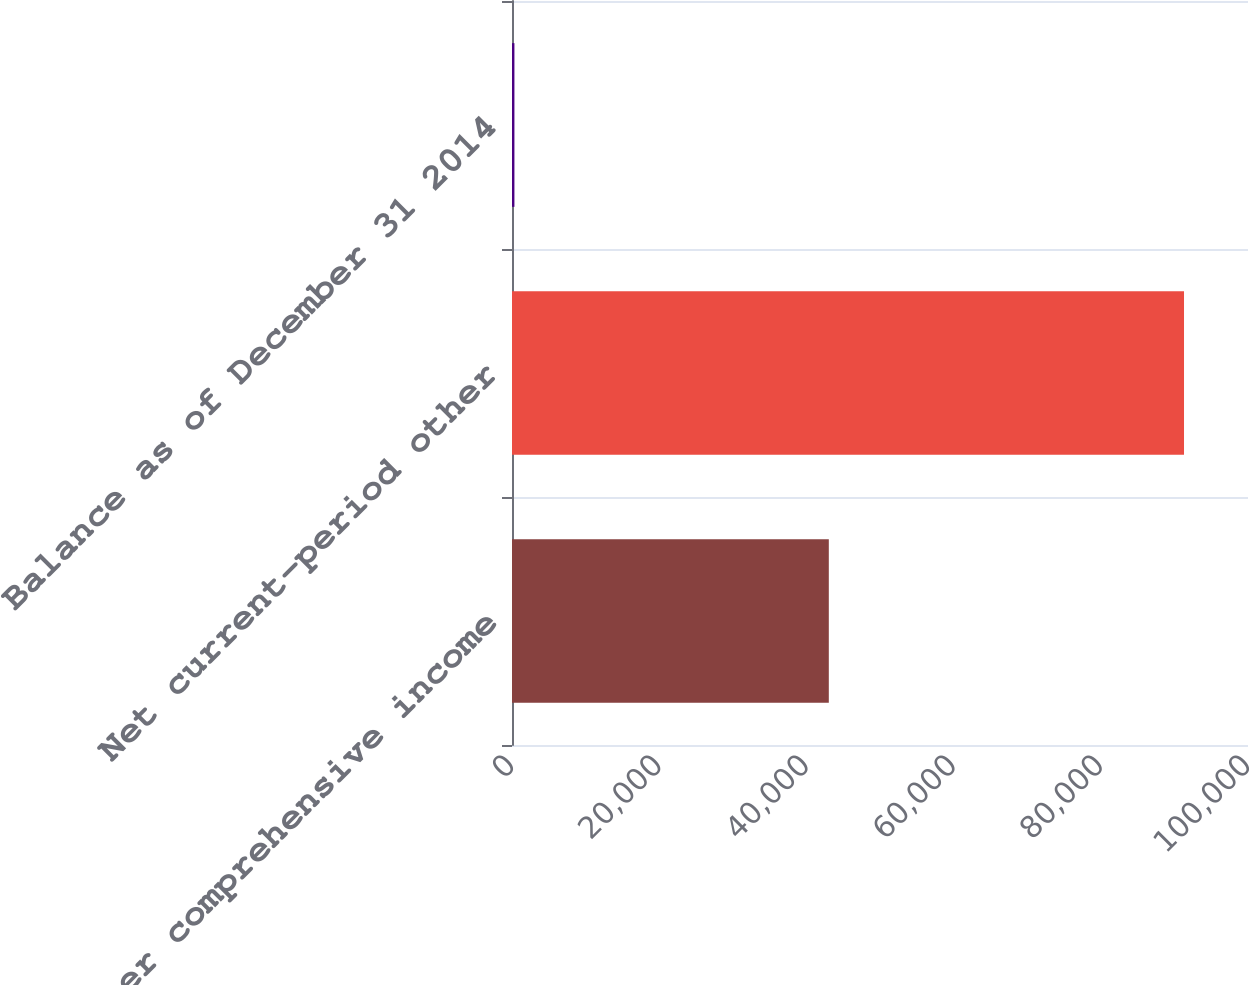Convert chart to OTSL. <chart><loc_0><loc_0><loc_500><loc_500><bar_chart><fcel>Other comprehensive income<fcel>Net current-period other<fcel>Balance as of December 31 2014<nl><fcel>43045<fcel>91306<fcel>329<nl></chart> 